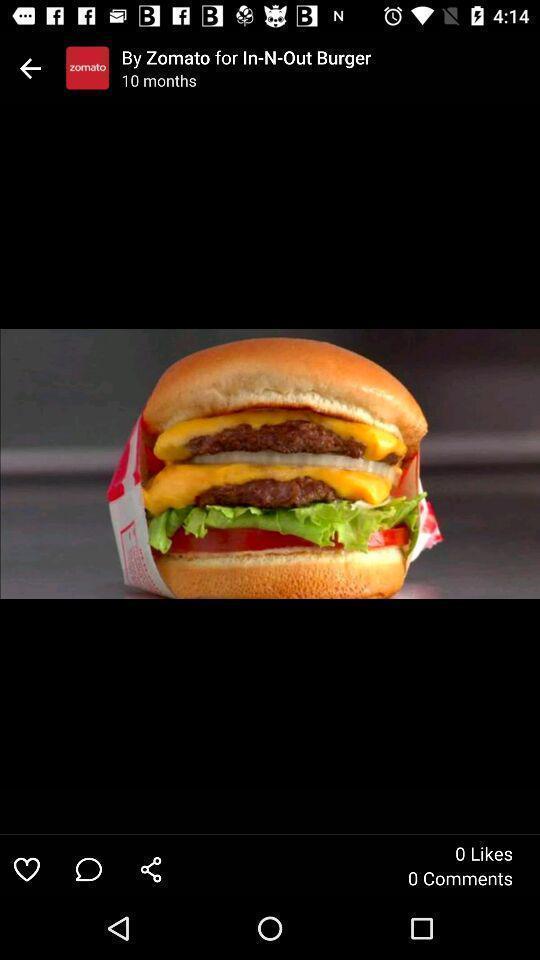Please provide a description for this image. Photo displaying on a page of a food app. 